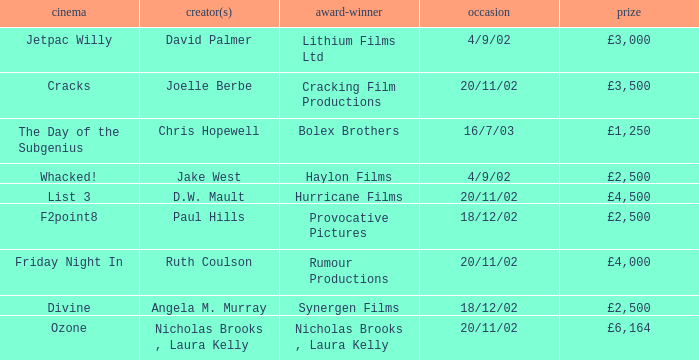What award did the film Ozone win? £6,164. 